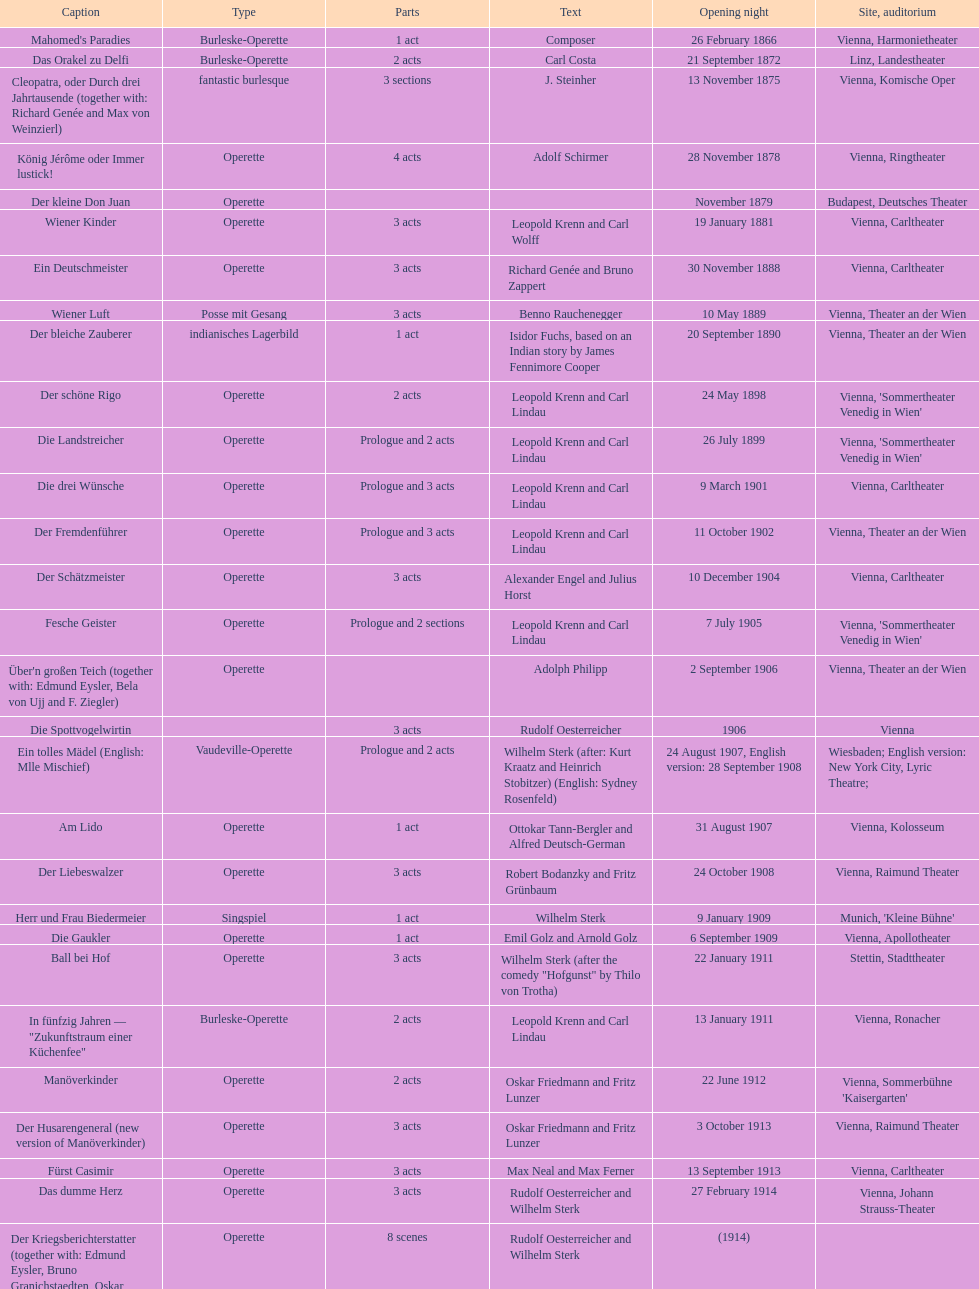Which year did he release his last operetta? 1930. 